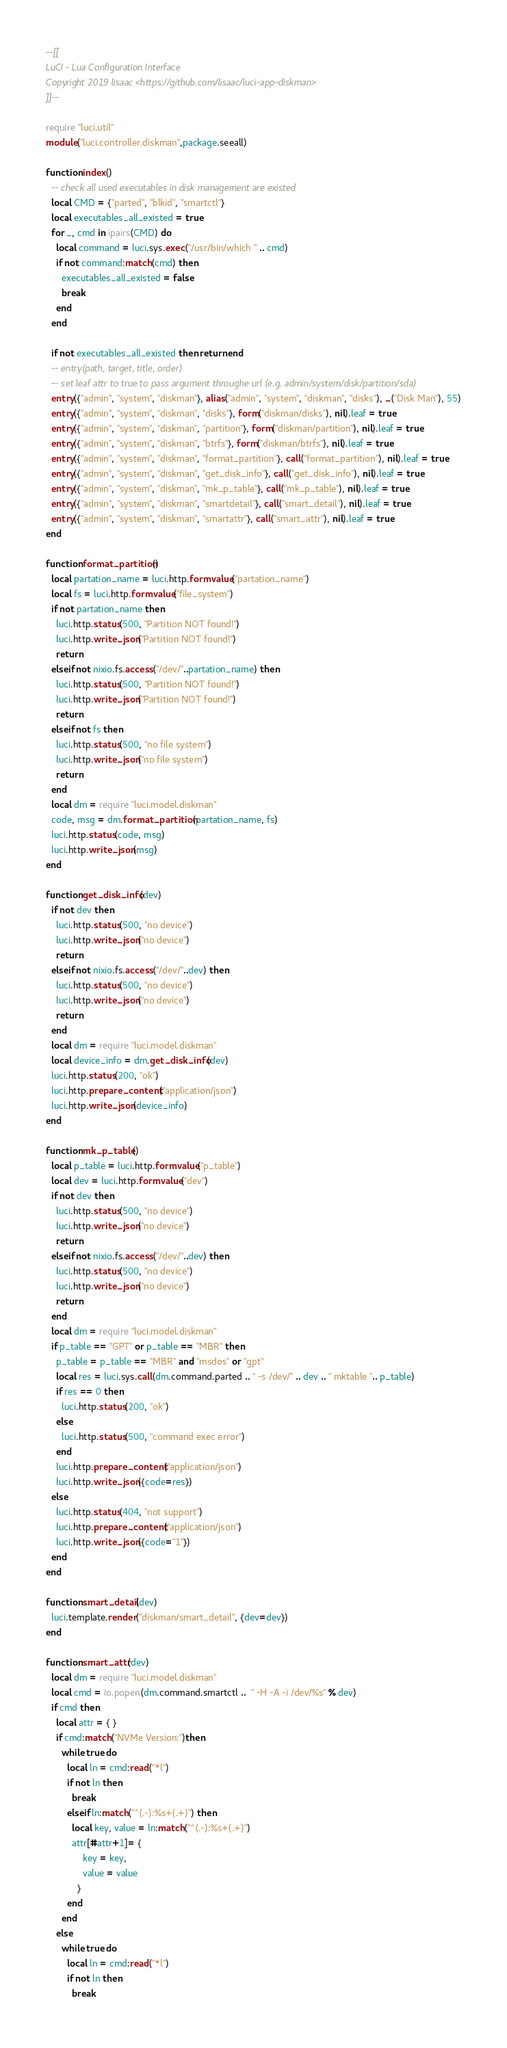<code> <loc_0><loc_0><loc_500><loc_500><_Lua_>--[[
LuCI - Lua Configuration Interface
Copyright 2019 lisaac <https://github.com/lisaac/luci-app-diskman>
]]--

require "luci.util"
module("luci.controller.diskman",package.seeall)

function index()
  -- check all used executables in disk management are existed
  local CMD = {"parted", "blkid", "smartctl"}
  local executables_all_existed = true
  for _, cmd in ipairs(CMD) do
    local command = luci.sys.exec("/usr/bin/which " .. cmd)
    if not command:match(cmd) then
      executables_all_existed = false
      break
    end
  end

  if not executables_all_existed then return end
  -- entry(path, target, title, order)
  -- set leaf attr to true to pass argument throughe url (e.g. admin/system/disk/partition/sda)
  entry({"admin", "system", "diskman"}, alias("admin", "system", "diskman", "disks"), _("Disk Man"), 55)
  entry({"admin", "system", "diskman", "disks"}, form("diskman/disks"), nil).leaf = true
  entry({"admin", "system", "diskman", "partition"}, form("diskman/partition"), nil).leaf = true
  entry({"admin", "system", "diskman", "btrfs"}, form("diskman/btrfs"), nil).leaf = true
  entry({"admin", "system", "diskman", "format_partition"}, call("format_partition"), nil).leaf = true
  entry({"admin", "system", "diskman", "get_disk_info"}, call("get_disk_info"), nil).leaf = true
  entry({"admin", "system", "diskman", "mk_p_table"}, call("mk_p_table"), nil).leaf = true
  entry({"admin", "system", "diskman", "smartdetail"}, call("smart_detail"), nil).leaf = true
  entry({"admin", "system", "diskman", "smartattr"}, call("smart_attr"), nil).leaf = true
end

function format_partition()
  local partation_name = luci.http.formvalue("partation_name")
  local fs = luci.http.formvalue("file_system")
  if not partation_name then
    luci.http.status(500, "Partition NOT found!")
    luci.http.write_json("Partition NOT found!")
    return
  elseif not nixio.fs.access("/dev/"..partation_name) then
    luci.http.status(500, "Partition NOT found!")
    luci.http.write_json("Partition NOT found!")
    return
  elseif not fs then
    luci.http.status(500, "no file system")
    luci.http.write_json("no file system")
    return
  end
  local dm = require "luci.model.diskman"
  code, msg = dm.format_partition(partation_name, fs)
  luci.http.status(code, msg)
  luci.http.write_json(msg)
end

function get_disk_info(dev)
  if not dev then
    luci.http.status(500, "no device")
    luci.http.write_json("no device")
    return
  elseif not nixio.fs.access("/dev/"..dev) then
    luci.http.status(500, "no device")
    luci.http.write_json("no device")
    return
  end
  local dm = require "luci.model.diskman"
  local device_info = dm.get_disk_info(dev)
  luci.http.status(200, "ok")
  luci.http.prepare_content("application/json")
  luci.http.write_json(device_info)
end

function mk_p_table()
  local p_table = luci.http.formvalue("p_table")
  local dev = luci.http.formvalue("dev")
  if not dev then
    luci.http.status(500, "no device")
    luci.http.write_json("no device")
    return
  elseif not nixio.fs.access("/dev/"..dev) then
    luci.http.status(500, "no device")
    luci.http.write_json("no device")
    return
  end
  local dm = require "luci.model.diskman"
  if p_table == "GPT" or p_table == "MBR" then
    p_table = p_table == "MBR" and "msdos" or "gpt"
    local res = luci.sys.call(dm.command.parted .. " -s /dev/" .. dev .. " mktable ".. p_table)
    if res == 0 then
      luci.http.status(200, "ok")
    else
      luci.http.status(500, "command exec error")
    end
    luci.http.prepare_content("application/json")
    luci.http.write_json({code=res})
  else
    luci.http.status(404, "not support")
    luci.http.prepare_content("application/json")
    luci.http.write_json({code="1"})
  end
end

function smart_detail(dev)
  luci.template.render("diskman/smart_detail", {dev=dev})
end

function smart_attr(dev)
  local dm = require "luci.model.diskman"
  local cmd = io.popen(dm.command.smartctl ..  " -H -A -i /dev/%s" % dev)
  if cmd then
    local attr = { }
    if cmd:match("NVMe Version:")then
      while true do
        local ln = cmd:read("*l")
        if not ln then
          break
        elseif ln:match("^(.-):%s+(.+)") then
          local key, value = ln:match("^(.-):%s+(.+)")
          attr[#attr+1]= {
              key = key,
              value = value
            }
        end
      end
    else
      while true do
        local ln = cmd:read("*l")
        if not ln then
          break</code> 